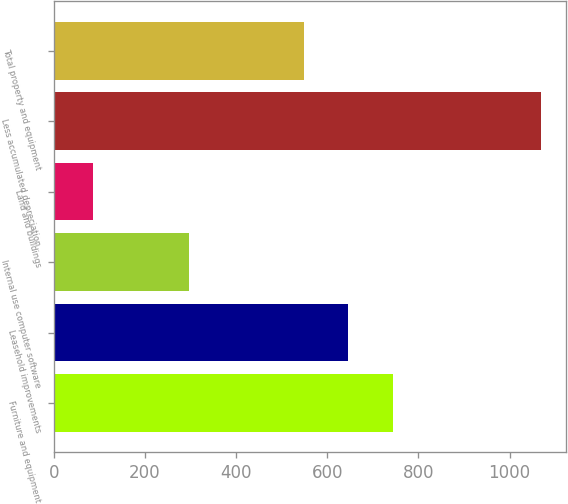Convert chart. <chart><loc_0><loc_0><loc_500><loc_500><bar_chart><fcel>Furniture and equipment<fcel>Leasehold improvements<fcel>Internal use computer software<fcel>Land and buildings<fcel>Less accumulated depreciation<fcel>Total property and equipment<nl><fcel>744.74<fcel>646.47<fcel>296.2<fcel>87.3<fcel>1070<fcel>548.2<nl></chart> 